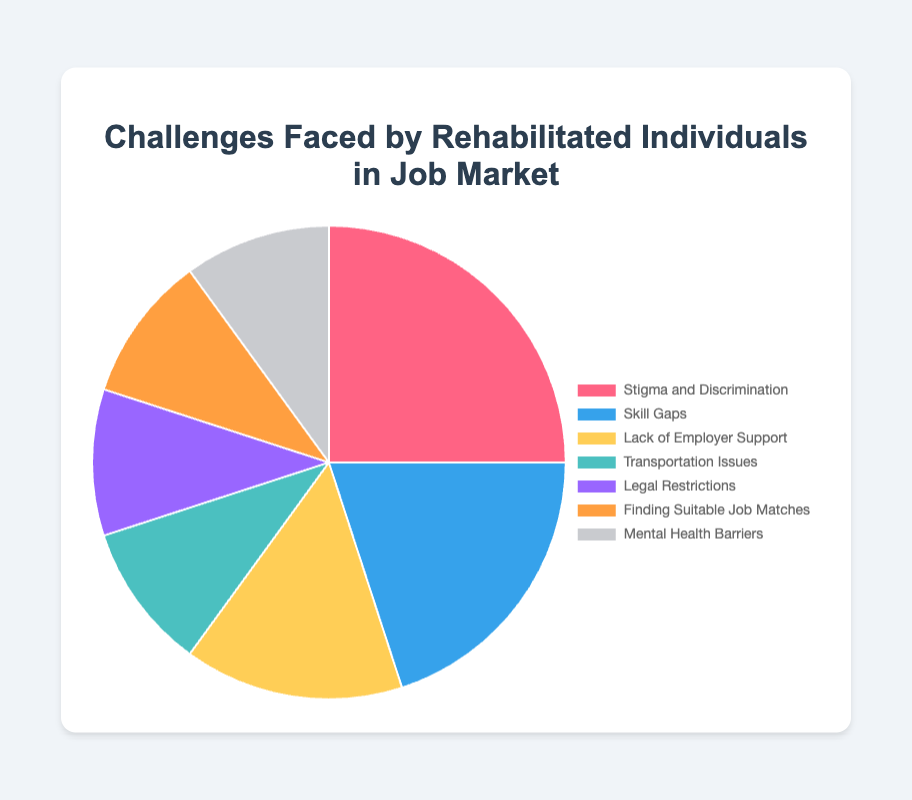Which category has the highest percentage? The chart shows that "Stigma and Discrimination" has the highest percentage, which is 25%.
Answer: Stigma and Discrimination What is the combined percentage of "Transportation Issues" and "Legal Restrictions"? "Transportation Issues" is 10% and "Legal Restrictions" is also 10%. By adding these two percentages, we get 10% + 10% = 20%.
Answer: 20% How does "Skill Gaps" compare to "Lack of Employer Support"? "Skill Gaps" has a percentage of 20%, whereas "Lack of Employer Support" has a percentage of 15%. Thus, "Skill Gaps" is greater by 5%.
Answer: "Skill Gaps" is 5% greater What is the percentage difference between the highest and lowest categories? The highest percentage is "Stigma and Discrimination" with 25%, and the lowest percentages are several categories tied at 10% ("Transportation Issues", "Legal Restrictions", "Finding Suitable Job Matches", and "Mental Health Barriers"). The difference is 25% - 10% = 15%.
Answer: 15% Which categories share the same percentage and what is that percentage? The categories "Transportation Issues", "Legal Restrictions", "Finding Suitable Job Matches", and "Mental Health Barriers" all share the same percentage of 10%.
Answer: 10% What is the sum of all percentages presented in the chart? By summing all the provided percentages: 25% + 20% + 15% + 10% + 10% + 10% + 10%, we get 100%.
Answer: 100% What fraction of the challenges is represented by "Finding Suitable Job Matches"? "Finding Suitable Job Matches" represents 10% of the chart. Since the total percentage is 100%, 10% can be written as the fraction 10/100, which simplifies to 1/10.
Answer: 1/10 Which category is represented by the yellow slice? The yellow slice is associated with "Lack of Employer Support" based on the pie chart's legend and color scheme.
Answer: Lack of Employer Support Group categories into two: those with 10% and those over 10%, what is the distribution between these two groups? Categories with 10% are "Transportation Issues", "Legal Restrictions", "Finding Suitable Job Matches", and "Mental Health Barriers". Categories over 10% are "Stigma and Discrimination" (25%), "Skill Gaps" (20%), and "Lack of Employer Support" (15%). There are 4 categories with 10%, and 3 categories over 10%.
Answer: 4 with 10%, 3 over 10% 